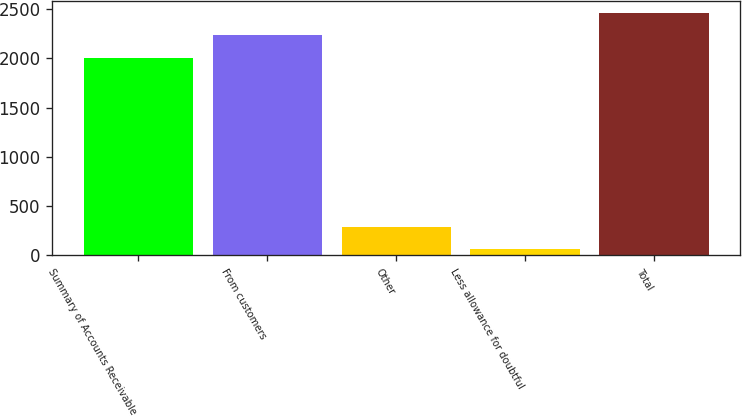<chart> <loc_0><loc_0><loc_500><loc_500><bar_chart><fcel>Summary of Accounts Receivable<fcel>From customers<fcel>Other<fcel>Less allowance for doubtful<fcel>Total<nl><fcel>2006<fcel>2233.8<fcel>286.5<fcel>58.7<fcel>2461.6<nl></chart> 